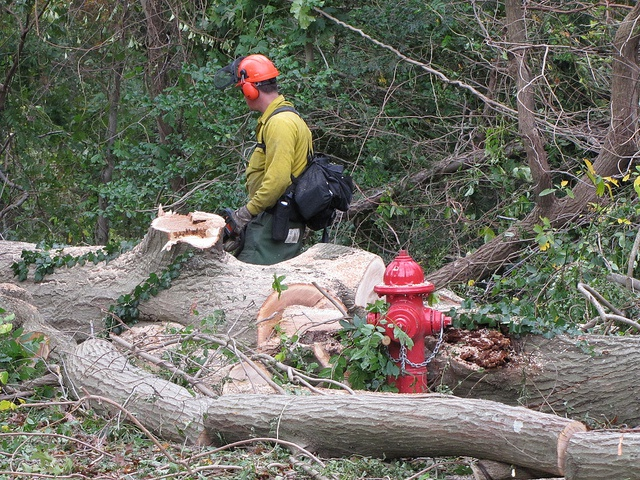Describe the objects in this image and their specific colors. I can see people in darkgreen, black, gray, and tan tones, fire hydrant in darkgreen, brown, salmon, and maroon tones, and backpack in darkgreen, black, and gray tones in this image. 